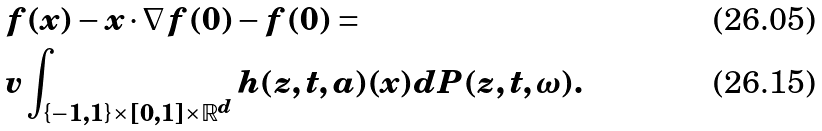Convert formula to latex. <formula><loc_0><loc_0><loc_500><loc_500>& f ( x ) - x \cdot \nabla f ( 0 ) - f ( 0 ) = \\ & v \int _ { \{ - 1 , 1 \} \times [ 0 , 1 ] \times \mathbb { R } ^ { d } } h ( z , t , a ) ( x ) d P ( z , t , \omega ) .</formula> 